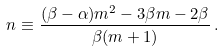Convert formula to latex. <formula><loc_0><loc_0><loc_500><loc_500>n \equiv \frac { ( \beta - \alpha ) m ^ { 2 } - 3 \beta m - 2 \beta } { \beta ( m + 1 ) } \, .</formula> 